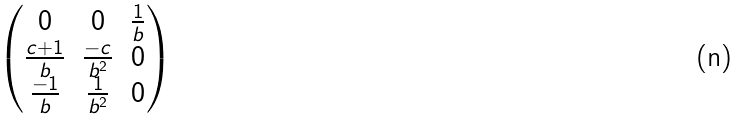Convert formula to latex. <formula><loc_0><loc_0><loc_500><loc_500>\begin{pmatrix} 0 & 0 & \frac { 1 } { b } \\ \frac { c + 1 } { b } & \frac { - c } { b ^ { 2 } } & 0 \\ \frac { - 1 } { b } & \frac { 1 } { b ^ { 2 } } & 0 \end{pmatrix}</formula> 